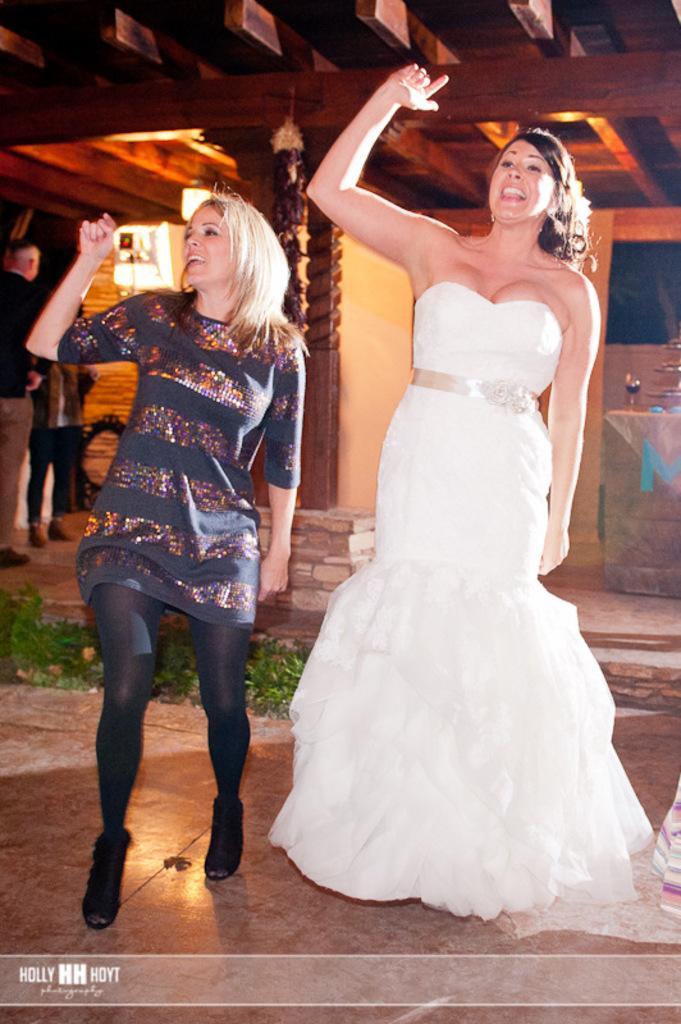In one or two sentences, can you explain what this image depicts? In this image we can see two people are dancing, on the top of there is a wooden roof and lights, in the background, we can see a wall, glass and two people standing. 